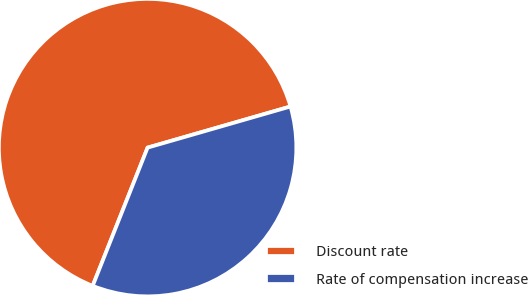Convert chart. <chart><loc_0><loc_0><loc_500><loc_500><pie_chart><fcel>Discount rate<fcel>Rate of compensation increase<nl><fcel>64.52%<fcel>35.48%<nl></chart> 